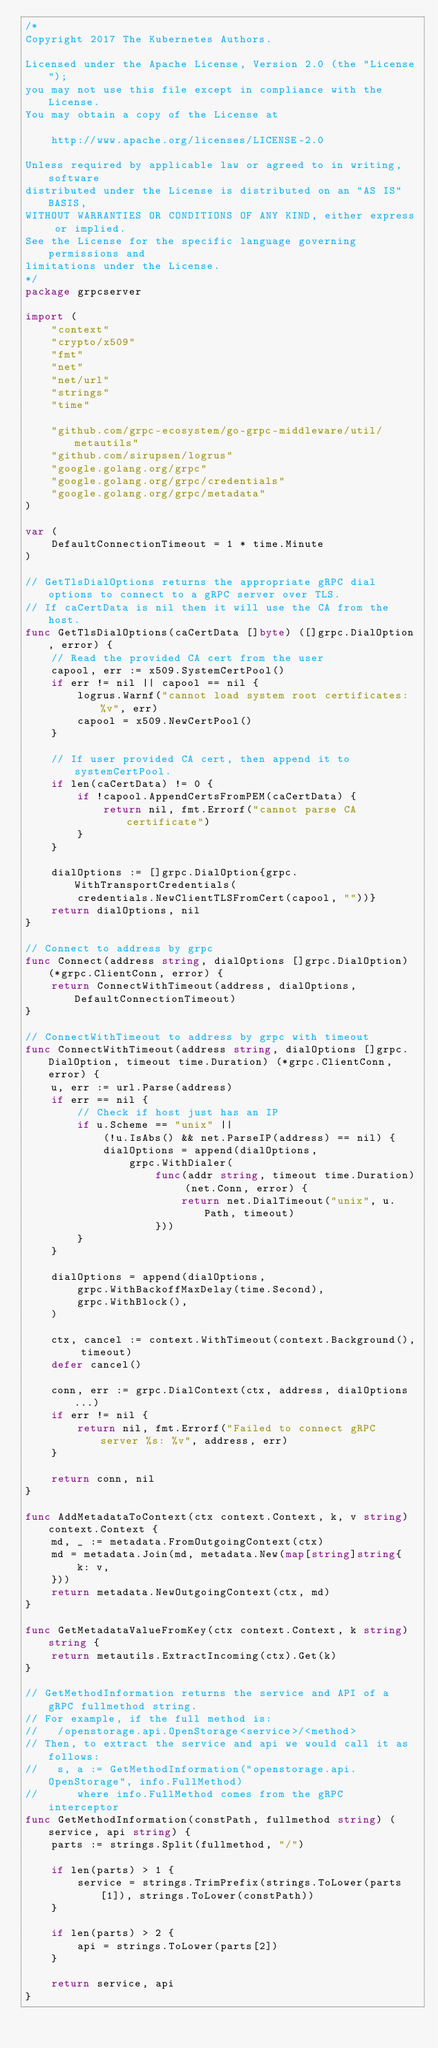<code> <loc_0><loc_0><loc_500><loc_500><_Go_>/*
Copyright 2017 The Kubernetes Authors.

Licensed under the Apache License, Version 2.0 (the "License");
you may not use this file except in compliance with the License.
You may obtain a copy of the License at

    http://www.apache.org/licenses/LICENSE-2.0

Unless required by applicable law or agreed to in writing, software
distributed under the License is distributed on an "AS IS" BASIS,
WITHOUT WARRANTIES OR CONDITIONS OF ANY KIND, either express or implied.
See the License for the specific language governing permissions and
limitations under the License.
*/
package grpcserver

import (
	"context"
	"crypto/x509"
	"fmt"
	"net"
	"net/url"
	"strings"
	"time"

	"github.com/grpc-ecosystem/go-grpc-middleware/util/metautils"
	"github.com/sirupsen/logrus"
	"google.golang.org/grpc"
	"google.golang.org/grpc/credentials"
	"google.golang.org/grpc/metadata"
)

var (
	DefaultConnectionTimeout = 1 * time.Minute
)

// GetTlsDialOptions returns the appropriate gRPC dial options to connect to a gRPC server over TLS.
// If caCertData is nil then it will use the CA from the host.
func GetTlsDialOptions(caCertData []byte) ([]grpc.DialOption, error) {
	// Read the provided CA cert from the user
	capool, err := x509.SystemCertPool()
	if err != nil || capool == nil {
		logrus.Warnf("cannot load system root certificates: %v", err)
		capool = x509.NewCertPool()
	}

	// If user provided CA cert, then append it to systemCertPool.
	if len(caCertData) != 0 {
		if !capool.AppendCertsFromPEM(caCertData) {
			return nil, fmt.Errorf("cannot parse CA certificate")
		}
	}

	dialOptions := []grpc.DialOption{grpc.WithTransportCredentials(
		credentials.NewClientTLSFromCert(capool, ""))}
	return dialOptions, nil
}

// Connect to address by grpc
func Connect(address string, dialOptions []grpc.DialOption) (*grpc.ClientConn, error) {
	return ConnectWithTimeout(address, dialOptions, DefaultConnectionTimeout)
}

// ConnectWithTimeout to address by grpc with timeout
func ConnectWithTimeout(address string, dialOptions []grpc.DialOption, timeout time.Duration) (*grpc.ClientConn, error) {
	u, err := url.Parse(address)
	if err == nil {
		// Check if host just has an IP
		if u.Scheme == "unix" ||
			(!u.IsAbs() && net.ParseIP(address) == nil) {
			dialOptions = append(dialOptions,
				grpc.WithDialer(
					func(addr string, timeout time.Duration) (net.Conn, error) {
						return net.DialTimeout("unix", u.Path, timeout)
					}))
		}
	}

	dialOptions = append(dialOptions,
		grpc.WithBackoffMaxDelay(time.Second),
		grpc.WithBlock(),
	)

	ctx, cancel := context.WithTimeout(context.Background(), timeout)
	defer cancel()

	conn, err := grpc.DialContext(ctx, address, dialOptions...)
	if err != nil {
		return nil, fmt.Errorf("Failed to connect gRPC server %s: %v", address, err)
	}

	return conn, nil
}

func AddMetadataToContext(ctx context.Context, k, v string) context.Context {
	md, _ := metadata.FromOutgoingContext(ctx)
	md = metadata.Join(md, metadata.New(map[string]string{
		k: v,
	}))
	return metadata.NewOutgoingContext(ctx, md)
}

func GetMetadataValueFromKey(ctx context.Context, k string) string {
	return metautils.ExtractIncoming(ctx).Get(k)
}

// GetMethodInformation returns the service and API of a gRPC fullmethod string.
// For example, if the full method is:
//   /openstorage.api.OpenStorage<service>/<method>
// Then, to extract the service and api we would call it as follows:
//   s, a := GetMethodInformation("openstorage.api.OpenStorage", info.FullMethod)
//      where info.FullMethod comes from the gRPC interceptor
func GetMethodInformation(constPath, fullmethod string) (service, api string) {
	parts := strings.Split(fullmethod, "/")

	if len(parts) > 1 {
		service = strings.TrimPrefix(strings.ToLower(parts[1]), strings.ToLower(constPath))
	}

	if len(parts) > 2 {
		api = strings.ToLower(parts[2])
	}

	return service, api
}
</code> 